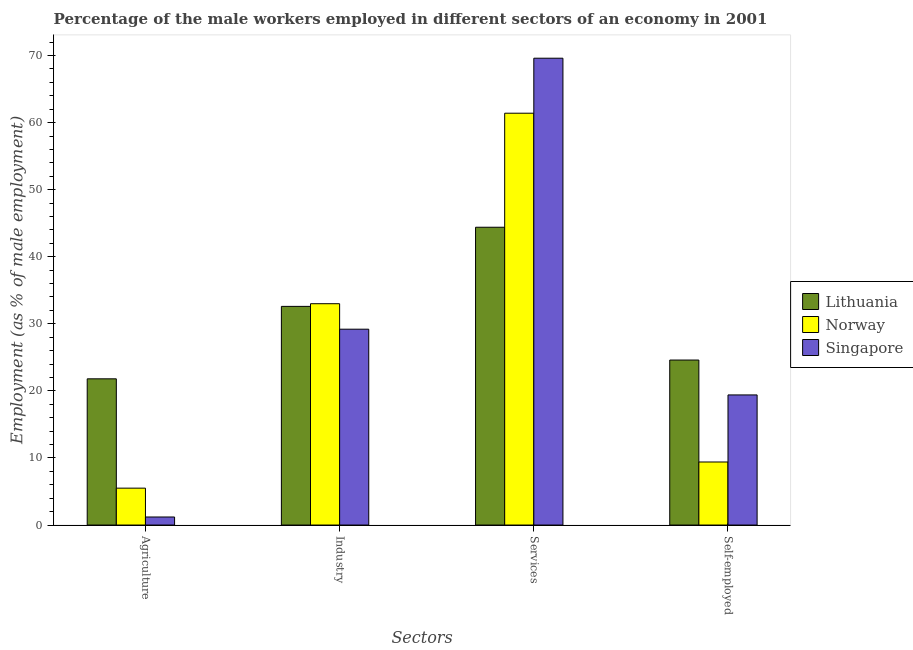How many groups of bars are there?
Provide a succinct answer. 4. Are the number of bars per tick equal to the number of legend labels?
Offer a terse response. Yes. Are the number of bars on each tick of the X-axis equal?
Keep it short and to the point. Yes. What is the label of the 2nd group of bars from the left?
Your answer should be very brief. Industry. What is the percentage of self employed male workers in Lithuania?
Give a very brief answer. 24.6. Across all countries, what is the maximum percentage of self employed male workers?
Your answer should be compact. 24.6. Across all countries, what is the minimum percentage of self employed male workers?
Keep it short and to the point. 9.4. In which country was the percentage of self employed male workers maximum?
Give a very brief answer. Lithuania. In which country was the percentage of male workers in agriculture minimum?
Make the answer very short. Singapore. What is the total percentage of self employed male workers in the graph?
Provide a short and direct response. 53.4. What is the difference between the percentage of male workers in agriculture in Singapore and that in Lithuania?
Your answer should be compact. -20.6. What is the difference between the percentage of self employed male workers in Norway and the percentage of male workers in agriculture in Lithuania?
Provide a succinct answer. -12.4. What is the average percentage of male workers in industry per country?
Give a very brief answer. 31.6. What is the difference between the percentage of self employed male workers and percentage of male workers in agriculture in Singapore?
Your answer should be very brief. 18.2. What is the ratio of the percentage of self employed male workers in Singapore to that in Lithuania?
Provide a short and direct response. 0.79. What is the difference between the highest and the second highest percentage of male workers in agriculture?
Offer a terse response. 16.3. What is the difference between the highest and the lowest percentage of self employed male workers?
Your response must be concise. 15.2. In how many countries, is the percentage of male workers in agriculture greater than the average percentage of male workers in agriculture taken over all countries?
Give a very brief answer. 1. Is the sum of the percentage of self employed male workers in Norway and Lithuania greater than the maximum percentage of male workers in agriculture across all countries?
Offer a terse response. Yes. What does the 1st bar from the left in Industry represents?
Provide a succinct answer. Lithuania. What does the 3rd bar from the right in Industry represents?
Your response must be concise. Lithuania. Are the values on the major ticks of Y-axis written in scientific E-notation?
Make the answer very short. No. Does the graph contain any zero values?
Your response must be concise. No. Does the graph contain grids?
Your answer should be compact. No. How many legend labels are there?
Provide a succinct answer. 3. How are the legend labels stacked?
Offer a very short reply. Vertical. What is the title of the graph?
Give a very brief answer. Percentage of the male workers employed in different sectors of an economy in 2001. What is the label or title of the X-axis?
Give a very brief answer. Sectors. What is the label or title of the Y-axis?
Make the answer very short. Employment (as % of male employment). What is the Employment (as % of male employment) of Lithuania in Agriculture?
Ensure brevity in your answer.  21.8. What is the Employment (as % of male employment) of Norway in Agriculture?
Ensure brevity in your answer.  5.5. What is the Employment (as % of male employment) of Singapore in Agriculture?
Give a very brief answer. 1.2. What is the Employment (as % of male employment) of Lithuania in Industry?
Keep it short and to the point. 32.6. What is the Employment (as % of male employment) of Norway in Industry?
Keep it short and to the point. 33. What is the Employment (as % of male employment) in Singapore in Industry?
Make the answer very short. 29.2. What is the Employment (as % of male employment) of Lithuania in Services?
Your answer should be very brief. 44.4. What is the Employment (as % of male employment) in Norway in Services?
Provide a short and direct response. 61.4. What is the Employment (as % of male employment) of Singapore in Services?
Your answer should be compact. 69.6. What is the Employment (as % of male employment) in Lithuania in Self-employed?
Offer a very short reply. 24.6. What is the Employment (as % of male employment) of Norway in Self-employed?
Your response must be concise. 9.4. What is the Employment (as % of male employment) in Singapore in Self-employed?
Your answer should be compact. 19.4. Across all Sectors, what is the maximum Employment (as % of male employment) of Lithuania?
Keep it short and to the point. 44.4. Across all Sectors, what is the maximum Employment (as % of male employment) in Norway?
Your answer should be compact. 61.4. Across all Sectors, what is the maximum Employment (as % of male employment) of Singapore?
Offer a very short reply. 69.6. Across all Sectors, what is the minimum Employment (as % of male employment) of Lithuania?
Provide a short and direct response. 21.8. Across all Sectors, what is the minimum Employment (as % of male employment) of Singapore?
Keep it short and to the point. 1.2. What is the total Employment (as % of male employment) in Lithuania in the graph?
Provide a succinct answer. 123.4. What is the total Employment (as % of male employment) in Norway in the graph?
Provide a succinct answer. 109.3. What is the total Employment (as % of male employment) of Singapore in the graph?
Provide a succinct answer. 119.4. What is the difference between the Employment (as % of male employment) of Lithuania in Agriculture and that in Industry?
Your response must be concise. -10.8. What is the difference between the Employment (as % of male employment) in Norway in Agriculture and that in Industry?
Your response must be concise. -27.5. What is the difference between the Employment (as % of male employment) of Singapore in Agriculture and that in Industry?
Keep it short and to the point. -28. What is the difference between the Employment (as % of male employment) in Lithuania in Agriculture and that in Services?
Offer a very short reply. -22.6. What is the difference between the Employment (as % of male employment) in Norway in Agriculture and that in Services?
Your response must be concise. -55.9. What is the difference between the Employment (as % of male employment) of Singapore in Agriculture and that in Services?
Offer a very short reply. -68.4. What is the difference between the Employment (as % of male employment) in Lithuania in Agriculture and that in Self-employed?
Your answer should be very brief. -2.8. What is the difference between the Employment (as % of male employment) of Singapore in Agriculture and that in Self-employed?
Offer a terse response. -18.2. What is the difference between the Employment (as % of male employment) of Norway in Industry and that in Services?
Ensure brevity in your answer.  -28.4. What is the difference between the Employment (as % of male employment) in Singapore in Industry and that in Services?
Keep it short and to the point. -40.4. What is the difference between the Employment (as % of male employment) in Norway in Industry and that in Self-employed?
Your response must be concise. 23.6. What is the difference between the Employment (as % of male employment) in Lithuania in Services and that in Self-employed?
Your answer should be compact. 19.8. What is the difference between the Employment (as % of male employment) in Norway in Services and that in Self-employed?
Your answer should be compact. 52. What is the difference between the Employment (as % of male employment) of Singapore in Services and that in Self-employed?
Ensure brevity in your answer.  50.2. What is the difference between the Employment (as % of male employment) of Norway in Agriculture and the Employment (as % of male employment) of Singapore in Industry?
Your answer should be very brief. -23.7. What is the difference between the Employment (as % of male employment) of Lithuania in Agriculture and the Employment (as % of male employment) of Norway in Services?
Provide a succinct answer. -39.6. What is the difference between the Employment (as % of male employment) of Lithuania in Agriculture and the Employment (as % of male employment) of Singapore in Services?
Provide a short and direct response. -47.8. What is the difference between the Employment (as % of male employment) in Norway in Agriculture and the Employment (as % of male employment) in Singapore in Services?
Ensure brevity in your answer.  -64.1. What is the difference between the Employment (as % of male employment) of Lithuania in Agriculture and the Employment (as % of male employment) of Norway in Self-employed?
Offer a terse response. 12.4. What is the difference between the Employment (as % of male employment) in Lithuania in Agriculture and the Employment (as % of male employment) in Singapore in Self-employed?
Keep it short and to the point. 2.4. What is the difference between the Employment (as % of male employment) of Lithuania in Industry and the Employment (as % of male employment) of Norway in Services?
Give a very brief answer. -28.8. What is the difference between the Employment (as % of male employment) in Lithuania in Industry and the Employment (as % of male employment) in Singapore in Services?
Your answer should be very brief. -37. What is the difference between the Employment (as % of male employment) in Norway in Industry and the Employment (as % of male employment) in Singapore in Services?
Your response must be concise. -36.6. What is the difference between the Employment (as % of male employment) of Lithuania in Industry and the Employment (as % of male employment) of Norway in Self-employed?
Make the answer very short. 23.2. What is the difference between the Employment (as % of male employment) in Lithuania in Industry and the Employment (as % of male employment) in Singapore in Self-employed?
Your answer should be compact. 13.2. What is the difference between the Employment (as % of male employment) of Lithuania in Services and the Employment (as % of male employment) of Norway in Self-employed?
Provide a succinct answer. 35. What is the difference between the Employment (as % of male employment) of Norway in Services and the Employment (as % of male employment) of Singapore in Self-employed?
Keep it short and to the point. 42. What is the average Employment (as % of male employment) of Lithuania per Sectors?
Your answer should be compact. 30.85. What is the average Employment (as % of male employment) in Norway per Sectors?
Your answer should be very brief. 27.32. What is the average Employment (as % of male employment) of Singapore per Sectors?
Ensure brevity in your answer.  29.85. What is the difference between the Employment (as % of male employment) of Lithuania and Employment (as % of male employment) of Norway in Agriculture?
Ensure brevity in your answer.  16.3. What is the difference between the Employment (as % of male employment) of Lithuania and Employment (as % of male employment) of Singapore in Agriculture?
Give a very brief answer. 20.6. What is the difference between the Employment (as % of male employment) of Lithuania and Employment (as % of male employment) of Singapore in Industry?
Provide a short and direct response. 3.4. What is the difference between the Employment (as % of male employment) in Lithuania and Employment (as % of male employment) in Singapore in Services?
Offer a very short reply. -25.2. What is the difference between the Employment (as % of male employment) of Norway and Employment (as % of male employment) of Singapore in Services?
Your answer should be compact. -8.2. What is the difference between the Employment (as % of male employment) of Norway and Employment (as % of male employment) of Singapore in Self-employed?
Your response must be concise. -10. What is the ratio of the Employment (as % of male employment) of Lithuania in Agriculture to that in Industry?
Your answer should be very brief. 0.67. What is the ratio of the Employment (as % of male employment) of Norway in Agriculture to that in Industry?
Provide a succinct answer. 0.17. What is the ratio of the Employment (as % of male employment) of Singapore in Agriculture to that in Industry?
Give a very brief answer. 0.04. What is the ratio of the Employment (as % of male employment) in Lithuania in Agriculture to that in Services?
Offer a very short reply. 0.49. What is the ratio of the Employment (as % of male employment) of Norway in Agriculture to that in Services?
Offer a very short reply. 0.09. What is the ratio of the Employment (as % of male employment) of Singapore in Agriculture to that in Services?
Your answer should be very brief. 0.02. What is the ratio of the Employment (as % of male employment) of Lithuania in Agriculture to that in Self-employed?
Provide a short and direct response. 0.89. What is the ratio of the Employment (as % of male employment) of Norway in Agriculture to that in Self-employed?
Your answer should be very brief. 0.59. What is the ratio of the Employment (as % of male employment) in Singapore in Agriculture to that in Self-employed?
Provide a succinct answer. 0.06. What is the ratio of the Employment (as % of male employment) in Lithuania in Industry to that in Services?
Your answer should be compact. 0.73. What is the ratio of the Employment (as % of male employment) in Norway in Industry to that in Services?
Ensure brevity in your answer.  0.54. What is the ratio of the Employment (as % of male employment) in Singapore in Industry to that in Services?
Ensure brevity in your answer.  0.42. What is the ratio of the Employment (as % of male employment) in Lithuania in Industry to that in Self-employed?
Your answer should be very brief. 1.33. What is the ratio of the Employment (as % of male employment) of Norway in Industry to that in Self-employed?
Your answer should be compact. 3.51. What is the ratio of the Employment (as % of male employment) in Singapore in Industry to that in Self-employed?
Offer a very short reply. 1.51. What is the ratio of the Employment (as % of male employment) in Lithuania in Services to that in Self-employed?
Provide a succinct answer. 1.8. What is the ratio of the Employment (as % of male employment) of Norway in Services to that in Self-employed?
Provide a short and direct response. 6.53. What is the ratio of the Employment (as % of male employment) in Singapore in Services to that in Self-employed?
Offer a terse response. 3.59. What is the difference between the highest and the second highest Employment (as % of male employment) of Norway?
Your response must be concise. 28.4. What is the difference between the highest and the second highest Employment (as % of male employment) of Singapore?
Your answer should be compact. 40.4. What is the difference between the highest and the lowest Employment (as % of male employment) in Lithuania?
Your answer should be very brief. 22.6. What is the difference between the highest and the lowest Employment (as % of male employment) in Norway?
Your answer should be compact. 55.9. What is the difference between the highest and the lowest Employment (as % of male employment) in Singapore?
Provide a succinct answer. 68.4. 